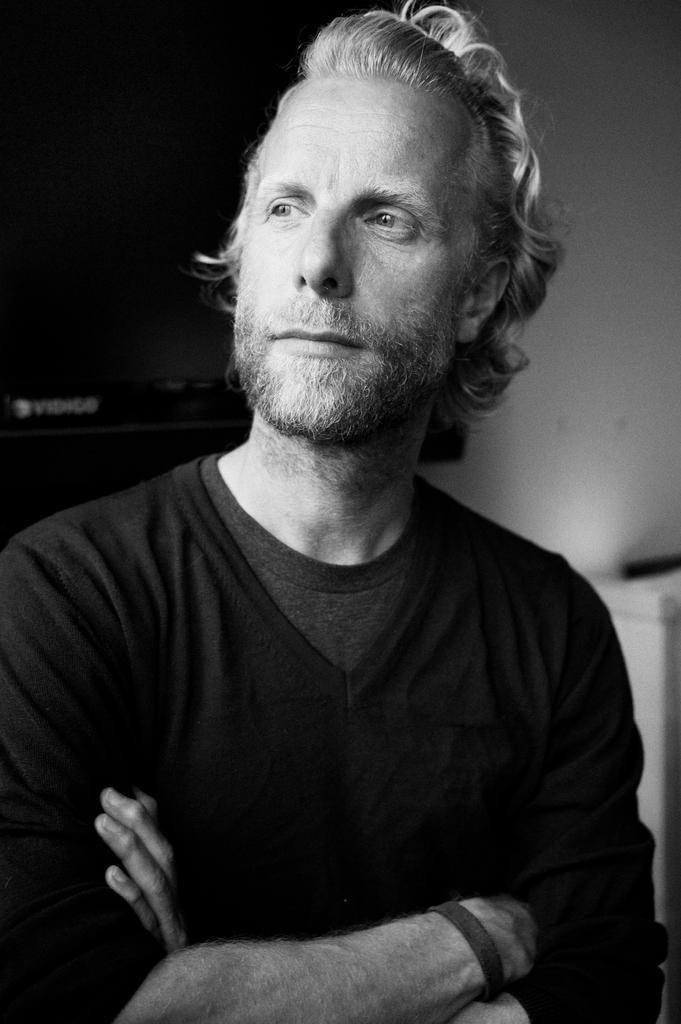Who is present in the image? There is a man in the image. What is the man wearing in the image? The man is wearing a black t-shirt. What can be seen in the background of the image? There is a white wall in the background of the image. What type of basket is the man holding in the image? There is no basket present in the image. Can you tell me the genre of the prose the man is reading in the image? There is no prose or reading material visible in the image. 